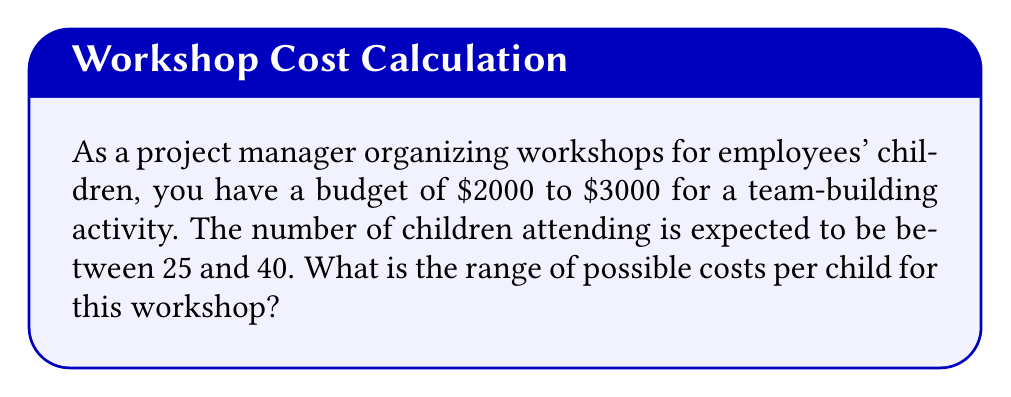Solve this math problem. To find the range of possible costs per child, we need to consider the minimum and maximum costs per child based on the given budget and attendance ranges.

Step 1: Identify the minimum and maximum budget
Minimum budget: $2000
Maximum budget: $3000

Step 2: Identify the minimum and maximum number of children
Minimum children: 25
Maximum children: 40

Step 3: Calculate the minimum cost per child
Minimum cost per child = Minimum budget ÷ Maximum children
$$ \text{Min cost/child} = \frac{\$2000}{40} = \$50 $$

Step 4: Calculate the maximum cost per child
Maximum cost per child = Maximum budget ÷ Minimum children
$$ \text{Max cost/child} = \frac{\$3000}{25} = \$120 $$

Step 5: Express the range of possible costs per child
The range of possible costs per child is from $50 to $120.

This can be written as an inequality:
$$ 50 \leq \text{cost per child} \leq 120 $$
Answer: $50 \leq \text{cost per child} \leq \$120$ 